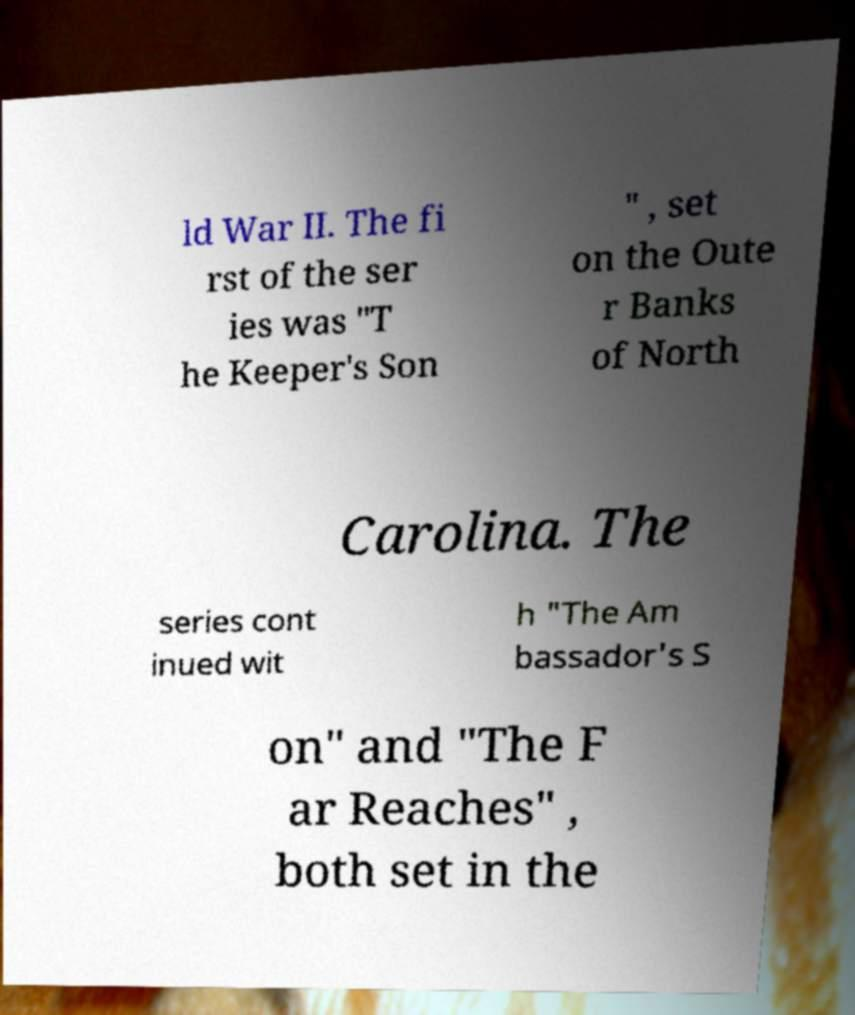Please identify and transcribe the text found in this image. ld War II. The fi rst of the ser ies was "T he Keeper's Son " , set on the Oute r Banks of North Carolina. The series cont inued wit h "The Am bassador's S on" and "The F ar Reaches" , both set in the 